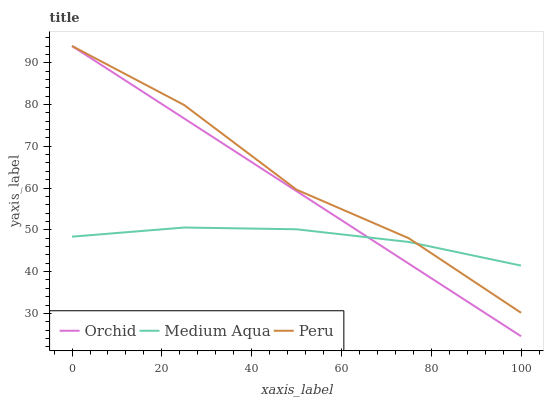Does Orchid have the minimum area under the curve?
Answer yes or no. No. Does Orchid have the maximum area under the curve?
Answer yes or no. No. Is Peru the smoothest?
Answer yes or no. No. Is Orchid the roughest?
Answer yes or no. No. Does Peru have the lowest value?
Answer yes or no. No. 